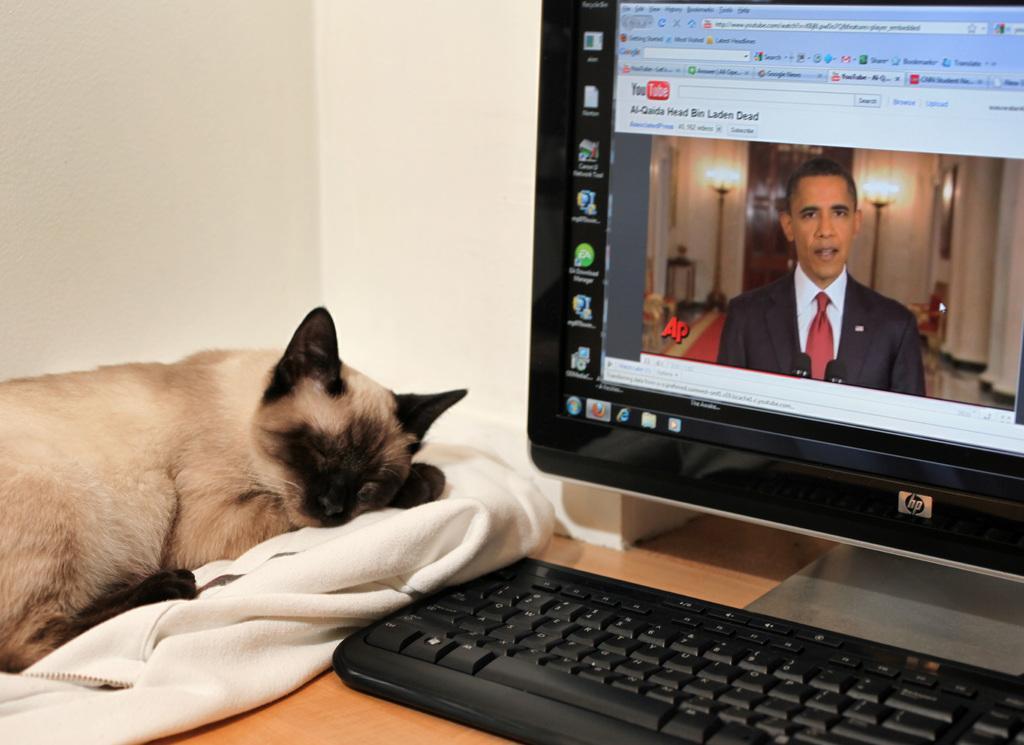Can you describe this image briefly? On the right side of the image, we can see a monitor and keyboard on the wooden surface. On the screen, we can see icons, text and person. On the left side of the image, there is a cat sleeping on the cloth. There is a white wall in the background. 